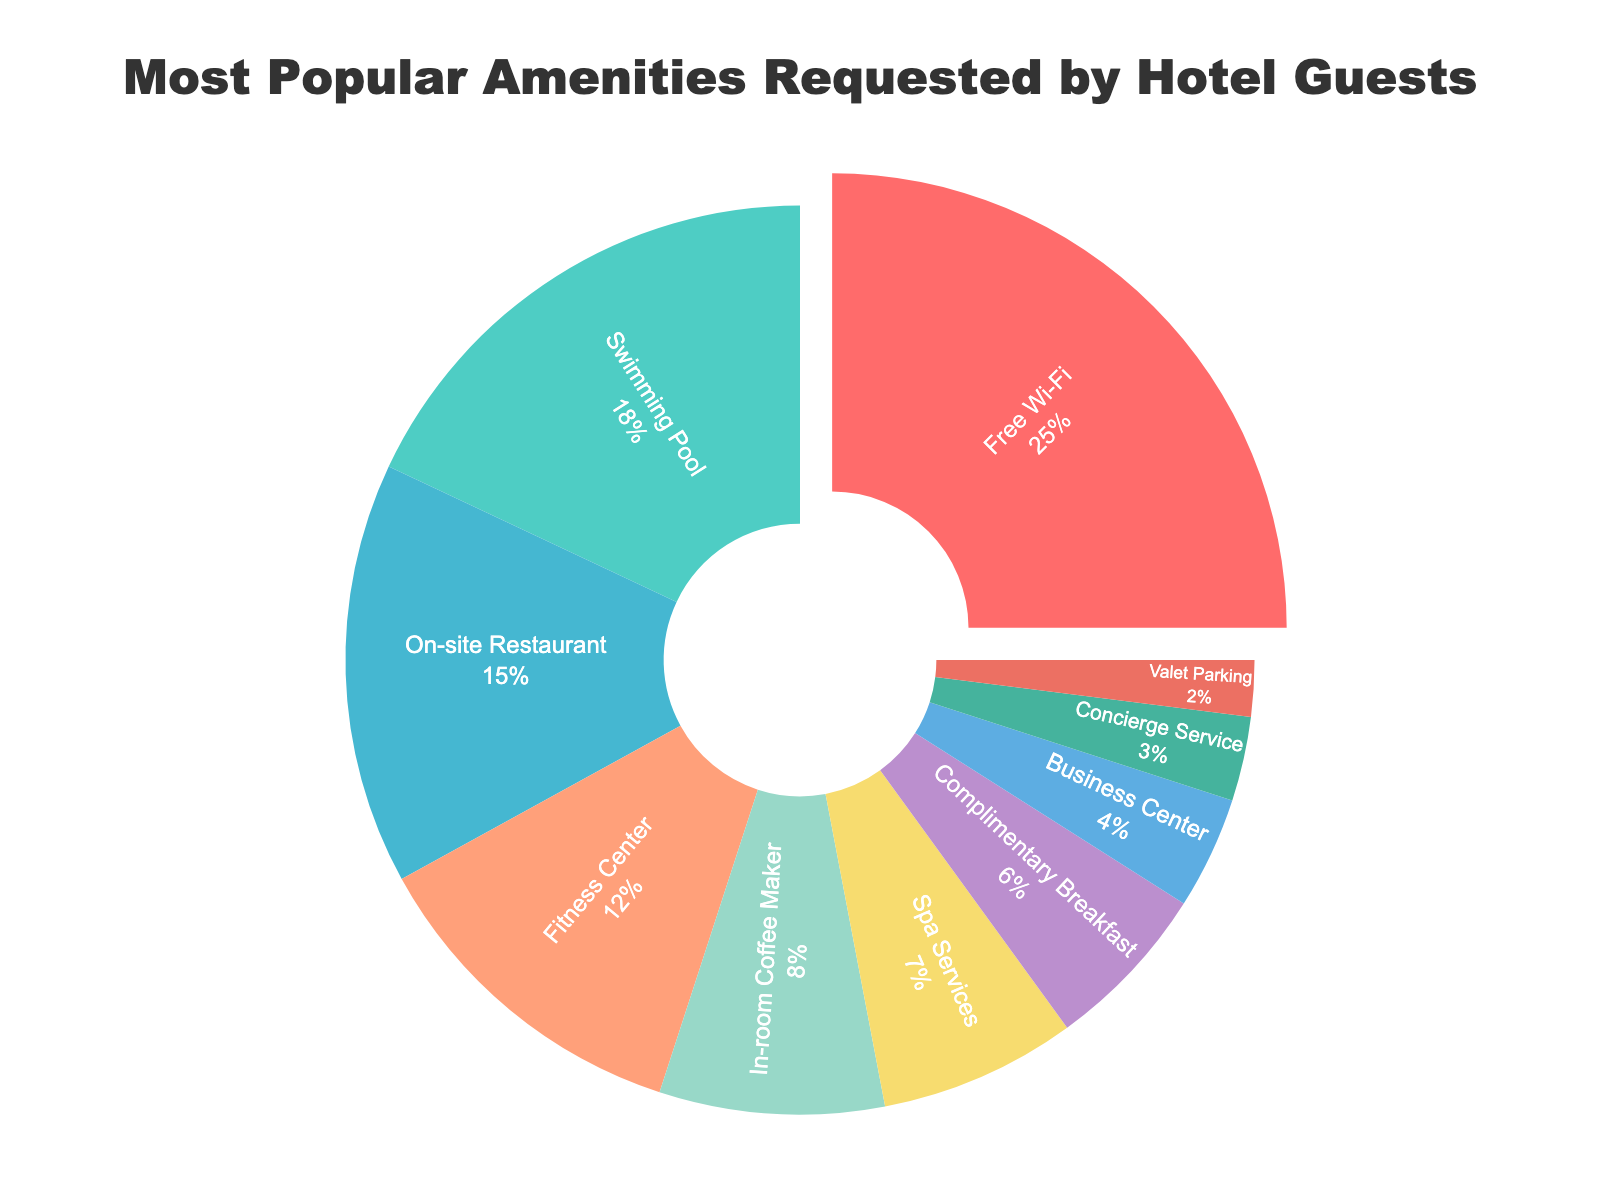What is the most requested amenity by hotel guests? The pie chart shows that "Free Wi-Fi" has the largest segment.
Answer: Free Wi-Fi Which amenity is requested more: Complimentary Breakfast or Spa Services? The pie chart indicates that "Spa Services" has a larger percentage (7%) compared to "Complimentary Breakfast" (6%).
Answer: Spa Services What is the combined percentage of Swimming Pool and Fitness Center requests? From the pie chart, Swimming Pool is 18% and Fitness Center is 12%. Adding these together: 18 + 12 = 30%.
Answer: 30% Is Business Center requested more or less than Concierge Service? The pie chart shows that Business Center has a higher percentage (4%) compared to Concierge Service (3%).
Answer: More What is the difference in percentage between the most and the least requested amenities? The most requested is Free Wi-Fi (25%) and the least requested is Valet Parking (2%). The difference is 25 - 2 = 23%.
Answer: 23% Which amenities together account for 33% of the requests? According to the pie chart, combining Free Wi-Fi (25%) and In-room Coffee Maker (8%) sums up: 25 + 8 = 33%.
Answer: Free Wi-Fi and In-room Coffee Maker What percentage of guests request either On-site Restaurant or Valet Parking? The pie chart shows On-site Restaurant accounts for 15% and Valet Parking for 2%, totaling: 15 + 2 = 17%.
Answer: 17% Is the percentage of requests for In-room Coffee Maker greater than half of the requests for Free Wi-Fi? Free Wi-Fi is 25%, and half of this is 12.5%. The In-room Coffee Maker is 8%, which is less than 12.5%.
Answer: No How many amenities have a percentage of 10% or higher? From the pie chart, the amenities are Free Wi-Fi (25%), Swimming Pool (18%), On-site Restaurant (15%), and Fitness Center (12%). This makes 4 amenities.
Answer: 4 Compare the total percentage of requests for amenities related to eating/drinking (Complimentary Breakfast, On-site Restaurant, and In-room Coffee Maker). The pie chart shows Complimentary Breakfast (6%), On-site Restaurant (15%), and In-room Coffee Maker (8%). Adding these: 6 + 15 + 8 = 29%.
Answer: 29% 